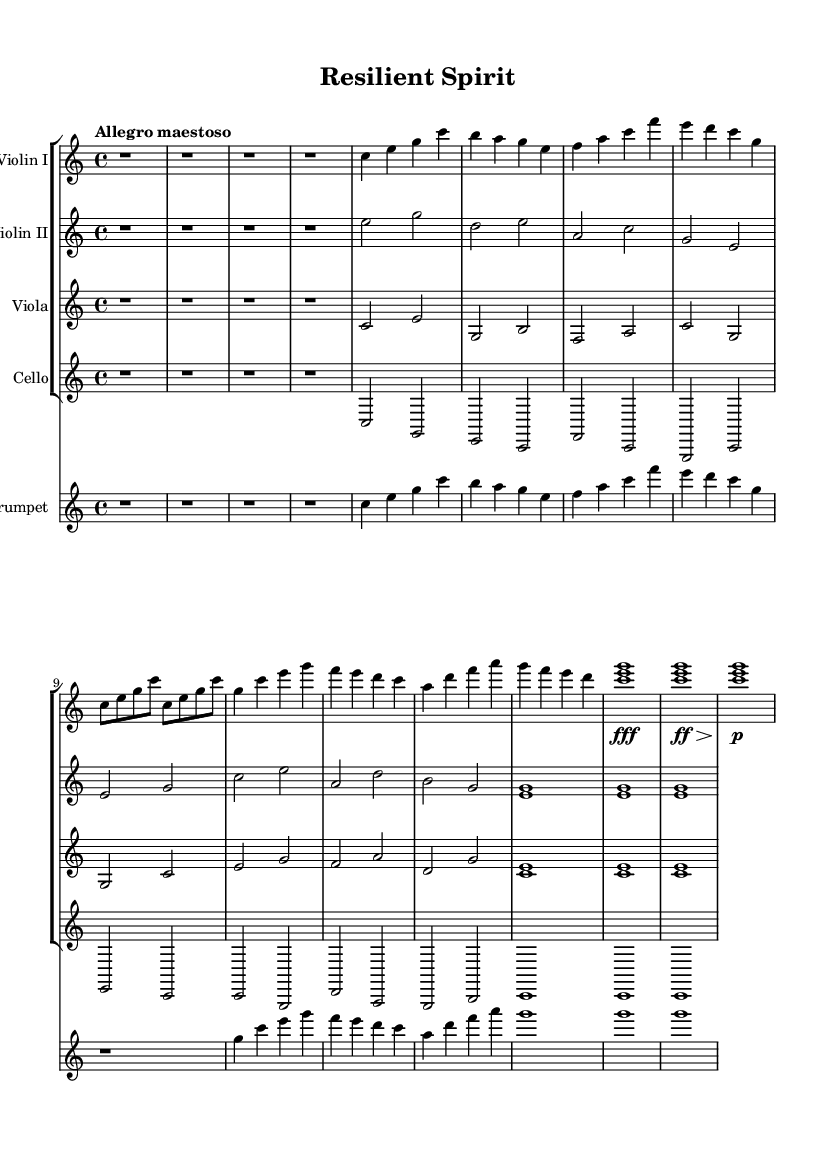What is the key signature of this music? The key signature indicates the music is in C major, which is shown by the absence of any sharps or flats in the key signature area.
Answer: C major What is the time signature of this piece? The time signature is found at the beginning of the score. It shows 4 over 4, meaning there are four beats in each measure and the quarter note gets one beat.
Answer: 4/4 What is the tempo marking of this piece? The tempo marking states "Allegro maestoso," which indicates a fast and majestic pace. It is typically played briskly but with a dignified character.
Answer: Allegro maestoso How many measures are in the introduction? The introduction consists of four rests, shown by r1, which means there are four measures of silence before the main theme starts.
Answer: 4 Which instrument plays the melody in the main theme? The main theme is primarily played by the Violin I part, as indicated by the music notation where the melodic lines are present.
Answer: Violin I What indicates the climax in the piece? The climax is indicated by the dynamics, shown as "fff" (forte fortissimo), followed by "ff" (forte) and then "p" (piano), suggesting a build-up and release of tension at the climax point.
Answer: Climax and Coda What is the overall mood of this orchestral piece? The overall mood can be inferred from the use of dynamics, tempo, and key, creating a triumphant and uplifting feel, typical of pieces celebrating resilience and comebacks.
Answer: Triumphant 